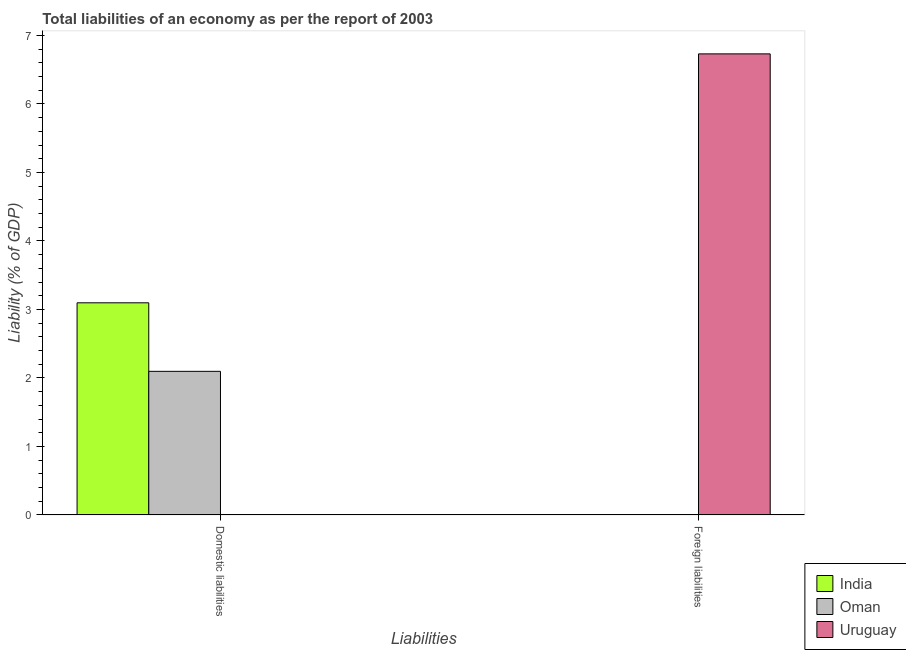How many different coloured bars are there?
Your answer should be compact. 3. Are the number of bars on each tick of the X-axis equal?
Make the answer very short. No. How many bars are there on the 2nd tick from the right?
Keep it short and to the point. 2. What is the label of the 2nd group of bars from the left?
Offer a very short reply. Foreign liabilities. Across all countries, what is the maximum incurrence of foreign liabilities?
Your answer should be very brief. 6.73. Across all countries, what is the minimum incurrence of foreign liabilities?
Your answer should be very brief. 0. In which country was the incurrence of foreign liabilities maximum?
Your answer should be very brief. Uruguay. What is the total incurrence of domestic liabilities in the graph?
Your answer should be compact. 5.19. What is the difference between the incurrence of domestic liabilities in India and that in Oman?
Provide a short and direct response. 1. What is the difference between the incurrence of domestic liabilities in Uruguay and the incurrence of foreign liabilities in India?
Provide a succinct answer. 0. What is the average incurrence of domestic liabilities per country?
Keep it short and to the point. 1.73. In how many countries, is the incurrence of domestic liabilities greater than 6.4 %?
Offer a very short reply. 0. Is the incurrence of domestic liabilities in Oman less than that in India?
Provide a succinct answer. Yes. In how many countries, is the incurrence of domestic liabilities greater than the average incurrence of domestic liabilities taken over all countries?
Provide a short and direct response. 2. How many bars are there?
Your response must be concise. 3. How many countries are there in the graph?
Your answer should be compact. 3. Are the values on the major ticks of Y-axis written in scientific E-notation?
Offer a terse response. No. What is the title of the graph?
Your answer should be compact. Total liabilities of an economy as per the report of 2003. Does "Turkey" appear as one of the legend labels in the graph?
Your answer should be compact. No. What is the label or title of the X-axis?
Offer a very short reply. Liabilities. What is the label or title of the Y-axis?
Your response must be concise. Liability (% of GDP). What is the Liability (% of GDP) of India in Domestic liabilities?
Your answer should be very brief. 3.1. What is the Liability (% of GDP) in Oman in Domestic liabilities?
Provide a succinct answer. 2.1. What is the Liability (% of GDP) of Uruguay in Foreign liabilities?
Provide a short and direct response. 6.73. Across all Liabilities, what is the maximum Liability (% of GDP) of India?
Provide a short and direct response. 3.1. Across all Liabilities, what is the maximum Liability (% of GDP) in Oman?
Offer a terse response. 2.1. Across all Liabilities, what is the maximum Liability (% of GDP) of Uruguay?
Your answer should be very brief. 6.73. Across all Liabilities, what is the minimum Liability (% of GDP) in Oman?
Provide a succinct answer. 0. What is the total Liability (% of GDP) in India in the graph?
Offer a terse response. 3.1. What is the total Liability (% of GDP) of Oman in the graph?
Make the answer very short. 2.1. What is the total Liability (% of GDP) in Uruguay in the graph?
Offer a terse response. 6.73. What is the difference between the Liability (% of GDP) of India in Domestic liabilities and the Liability (% of GDP) of Uruguay in Foreign liabilities?
Provide a succinct answer. -3.63. What is the difference between the Liability (% of GDP) of Oman in Domestic liabilities and the Liability (% of GDP) of Uruguay in Foreign liabilities?
Your answer should be very brief. -4.63. What is the average Liability (% of GDP) in India per Liabilities?
Provide a succinct answer. 1.55. What is the average Liability (% of GDP) of Oman per Liabilities?
Your answer should be very brief. 1.05. What is the average Liability (% of GDP) in Uruguay per Liabilities?
Keep it short and to the point. 3.37. What is the difference between the highest and the lowest Liability (% of GDP) of India?
Offer a very short reply. 3.1. What is the difference between the highest and the lowest Liability (% of GDP) in Oman?
Offer a terse response. 2.1. What is the difference between the highest and the lowest Liability (% of GDP) of Uruguay?
Offer a very short reply. 6.73. 